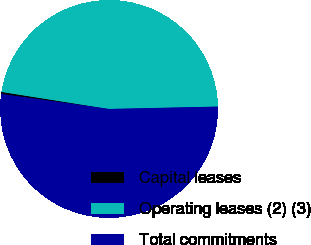Convert chart. <chart><loc_0><loc_0><loc_500><loc_500><pie_chart><fcel>Capital leases<fcel>Operating leases (2) (3)<fcel>Total commitments<nl><fcel>0.3%<fcel>47.15%<fcel>52.55%<nl></chart> 